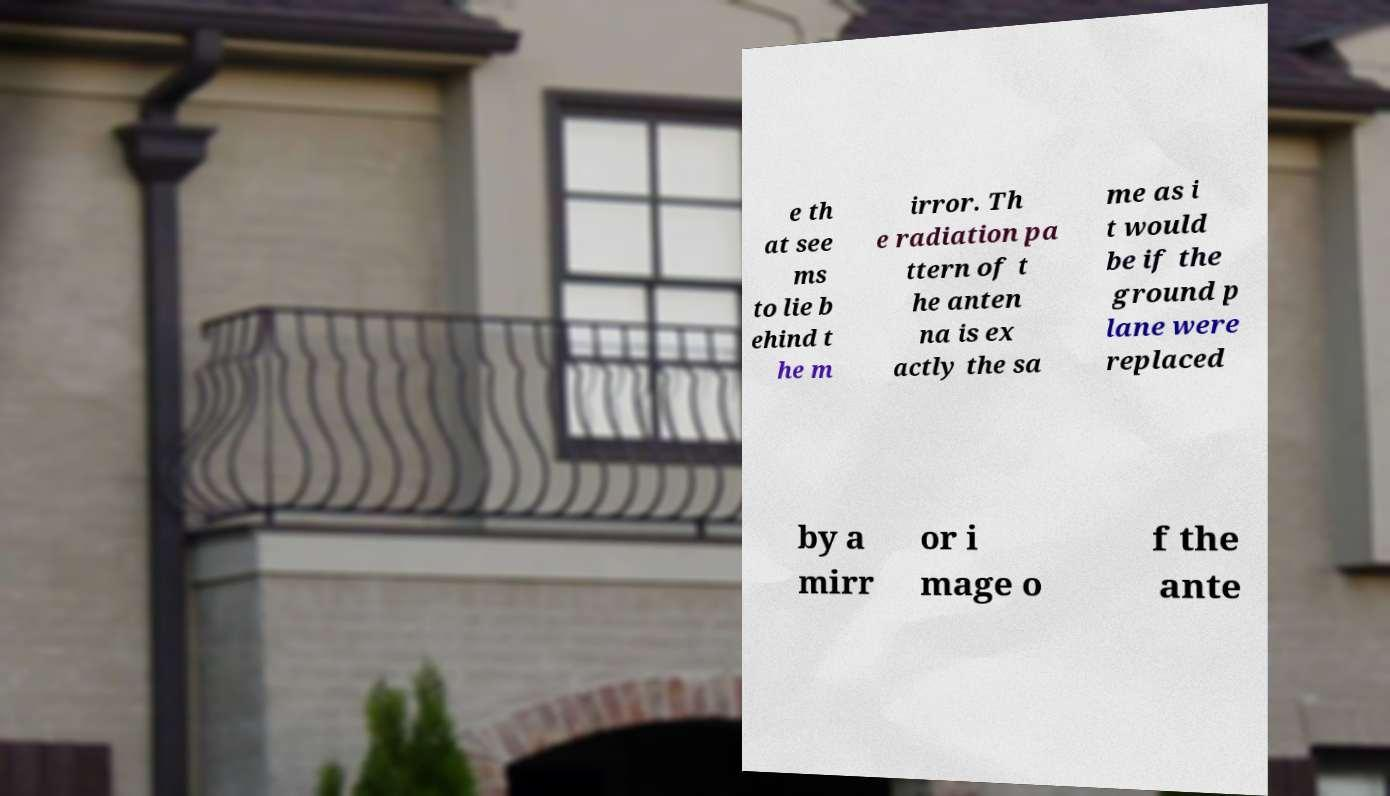There's text embedded in this image that I need extracted. Can you transcribe it verbatim? e th at see ms to lie b ehind t he m irror. Th e radiation pa ttern of t he anten na is ex actly the sa me as i t would be if the ground p lane were replaced by a mirr or i mage o f the ante 